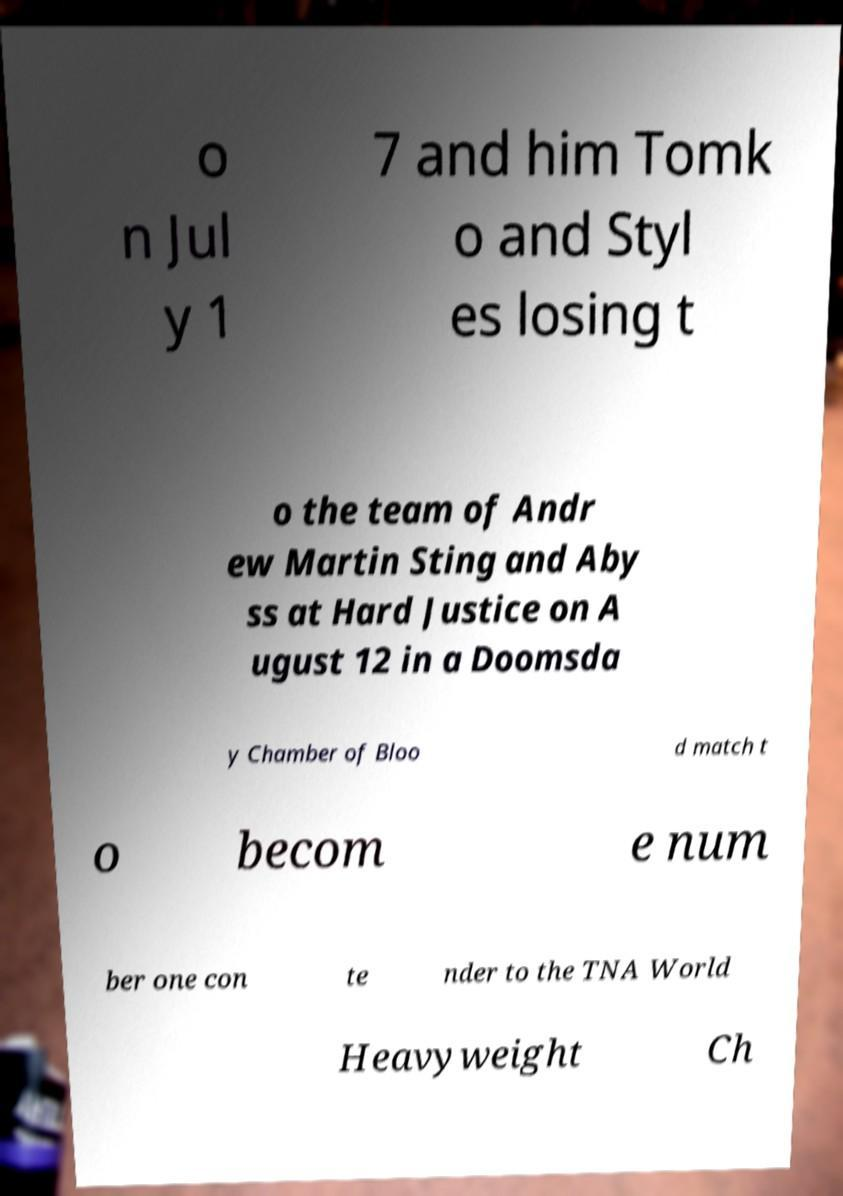Please identify and transcribe the text found in this image. o n Jul y 1 7 and him Tomk o and Styl es losing t o the team of Andr ew Martin Sting and Aby ss at Hard Justice on A ugust 12 in a Doomsda y Chamber of Bloo d match t o becom e num ber one con te nder to the TNA World Heavyweight Ch 